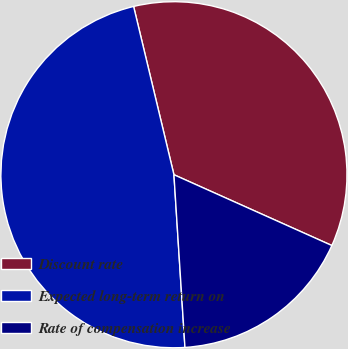Convert chart to OTSL. <chart><loc_0><loc_0><loc_500><loc_500><pie_chart><fcel>Discount rate<fcel>Expected long-term return on<fcel>Rate of compensation increase<nl><fcel>35.45%<fcel>47.27%<fcel>17.28%<nl></chart> 